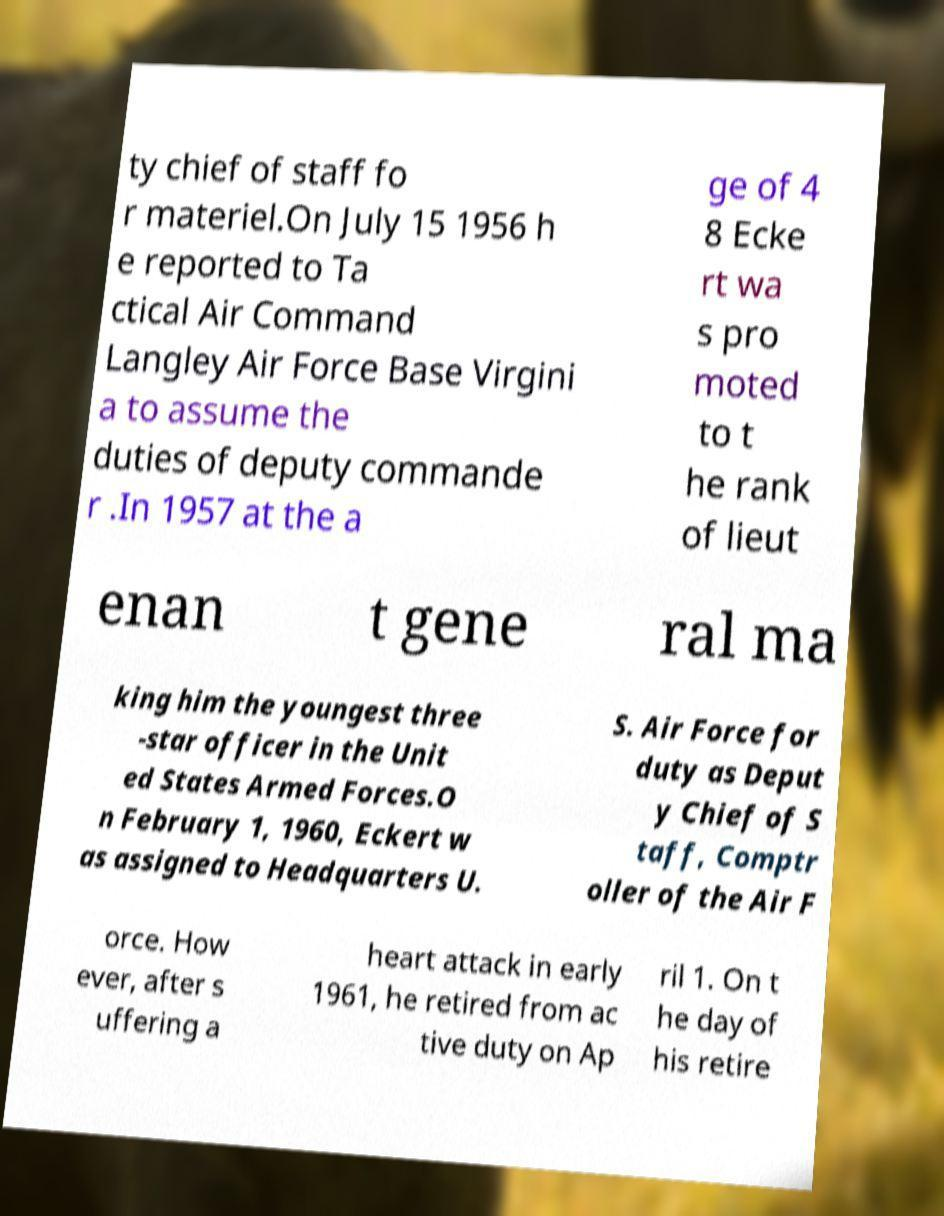Could you assist in decoding the text presented in this image and type it out clearly? ty chief of staff fo r materiel.On July 15 1956 h e reported to Ta ctical Air Command Langley Air Force Base Virgini a to assume the duties of deputy commande r .In 1957 at the a ge of 4 8 Ecke rt wa s pro moted to t he rank of lieut enan t gene ral ma king him the youngest three -star officer in the Unit ed States Armed Forces.O n February 1, 1960, Eckert w as assigned to Headquarters U. S. Air Force for duty as Deput y Chief of S taff, Comptr oller of the Air F orce. How ever, after s uffering a heart attack in early 1961, he retired from ac tive duty on Ap ril 1. On t he day of his retire 